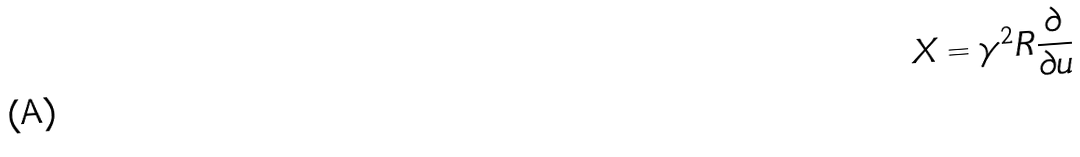Convert formula to latex. <formula><loc_0><loc_0><loc_500><loc_500>X = \gamma ^ { 2 } R \frac { \partial } { \partial u }</formula> 